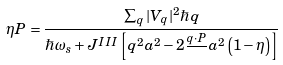<formula> <loc_0><loc_0><loc_500><loc_500>\eta { P } = \frac { \sum _ { q } | V _ { q } | ^ { 2 } \hbar { q } } { \hbar { \omega } _ { s } + J ^ { I I I } \left [ q ^ { 2 } a ^ { 2 } - 2 \frac { { q } \cdot { P } } { } a ^ { 2 } \left ( 1 - \eta \right ) \right ] }</formula> 